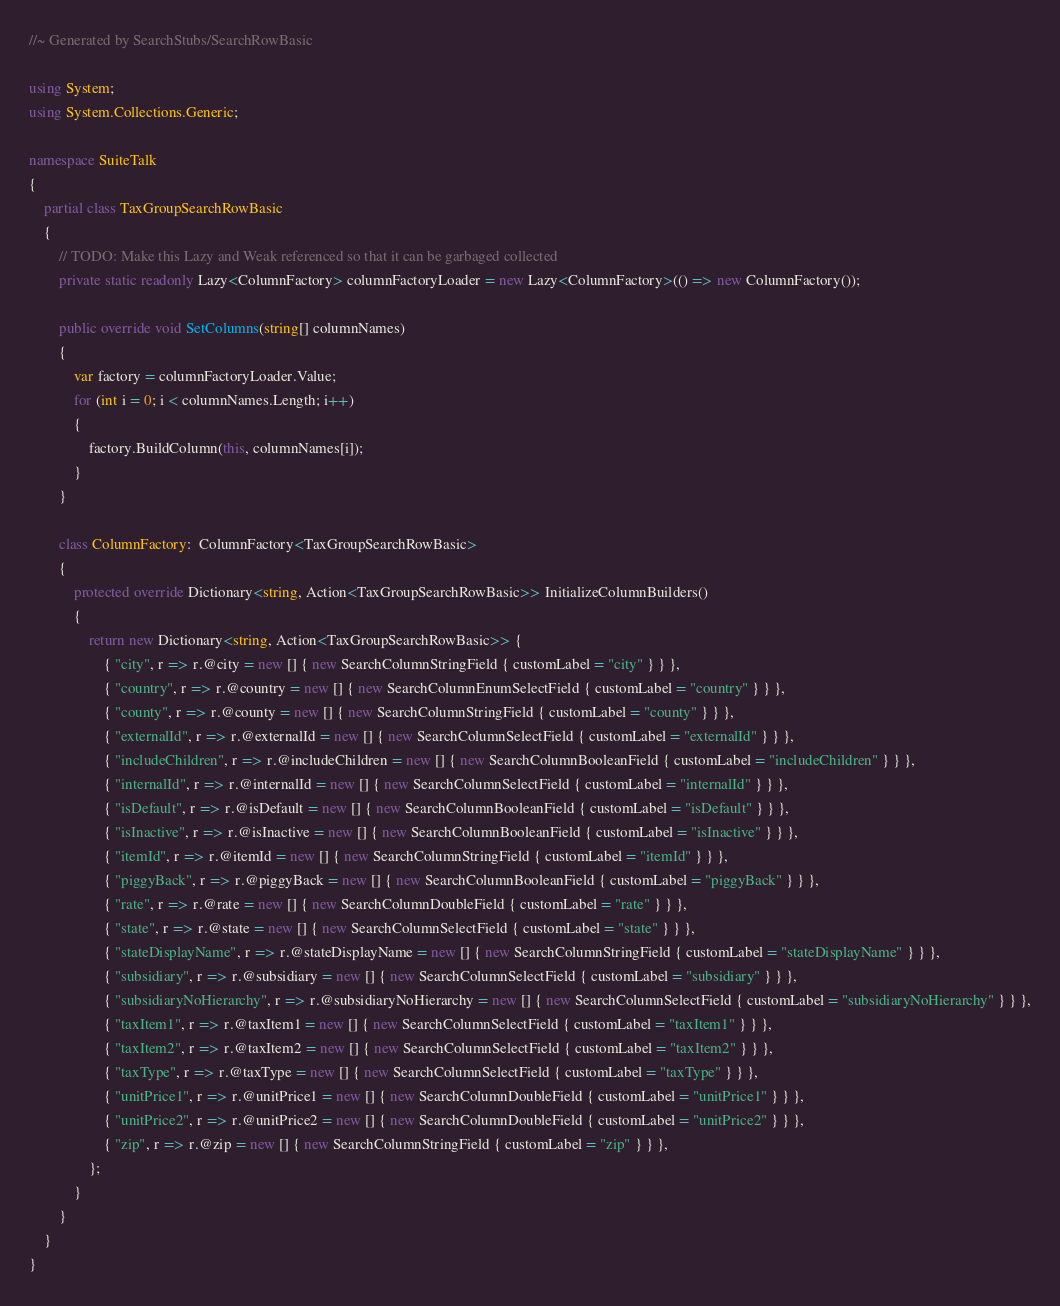Convert code to text. <code><loc_0><loc_0><loc_500><loc_500><_C#_>//~ Generated by SearchStubs/SearchRowBasic

using System;
using System.Collections.Generic;

namespace SuiteTalk
{
    partial class TaxGroupSearchRowBasic
    {
        // TODO: Make this Lazy and Weak referenced so that it can be garbaged collected
        private static readonly Lazy<ColumnFactory> columnFactoryLoader = new Lazy<ColumnFactory>(() => new ColumnFactory());

        public override void SetColumns(string[] columnNames)
        {
            var factory = columnFactoryLoader.Value;
            for (int i = 0; i < columnNames.Length; i++)
            {
                factory.BuildColumn(this, columnNames[i]);
            }
        }

        class ColumnFactory:  ColumnFactory<TaxGroupSearchRowBasic>
        {
            protected override Dictionary<string, Action<TaxGroupSearchRowBasic>> InitializeColumnBuilders()
            {
                return new Dictionary<string, Action<TaxGroupSearchRowBasic>> {
                    { "city", r => r.@city = new [] { new SearchColumnStringField { customLabel = "city" } } },
                    { "country", r => r.@country = new [] { new SearchColumnEnumSelectField { customLabel = "country" } } },
                    { "county", r => r.@county = new [] { new SearchColumnStringField { customLabel = "county" } } },
                    { "externalId", r => r.@externalId = new [] { new SearchColumnSelectField { customLabel = "externalId" } } },
                    { "includeChildren", r => r.@includeChildren = new [] { new SearchColumnBooleanField { customLabel = "includeChildren" } } },
                    { "internalId", r => r.@internalId = new [] { new SearchColumnSelectField { customLabel = "internalId" } } },
                    { "isDefault", r => r.@isDefault = new [] { new SearchColumnBooleanField { customLabel = "isDefault" } } },
                    { "isInactive", r => r.@isInactive = new [] { new SearchColumnBooleanField { customLabel = "isInactive" } } },
                    { "itemId", r => r.@itemId = new [] { new SearchColumnStringField { customLabel = "itemId" } } },
                    { "piggyBack", r => r.@piggyBack = new [] { new SearchColumnBooleanField { customLabel = "piggyBack" } } },
                    { "rate", r => r.@rate = new [] { new SearchColumnDoubleField { customLabel = "rate" } } },
                    { "state", r => r.@state = new [] { new SearchColumnSelectField { customLabel = "state" } } },
                    { "stateDisplayName", r => r.@stateDisplayName = new [] { new SearchColumnStringField { customLabel = "stateDisplayName" } } },
                    { "subsidiary", r => r.@subsidiary = new [] { new SearchColumnSelectField { customLabel = "subsidiary" } } },
                    { "subsidiaryNoHierarchy", r => r.@subsidiaryNoHierarchy = new [] { new SearchColumnSelectField { customLabel = "subsidiaryNoHierarchy" } } },
                    { "taxItem1", r => r.@taxItem1 = new [] { new SearchColumnSelectField { customLabel = "taxItem1" } } },
                    { "taxItem2", r => r.@taxItem2 = new [] { new SearchColumnSelectField { customLabel = "taxItem2" } } },
                    { "taxType", r => r.@taxType = new [] { new SearchColumnSelectField { customLabel = "taxType" } } },
                    { "unitPrice1", r => r.@unitPrice1 = new [] { new SearchColumnDoubleField { customLabel = "unitPrice1" } } },
                    { "unitPrice2", r => r.@unitPrice2 = new [] { new SearchColumnDoubleField { customLabel = "unitPrice2" } } },
                    { "zip", r => r.@zip = new [] { new SearchColumnStringField { customLabel = "zip" } } },
                };
            }
        }
    }
}</code> 